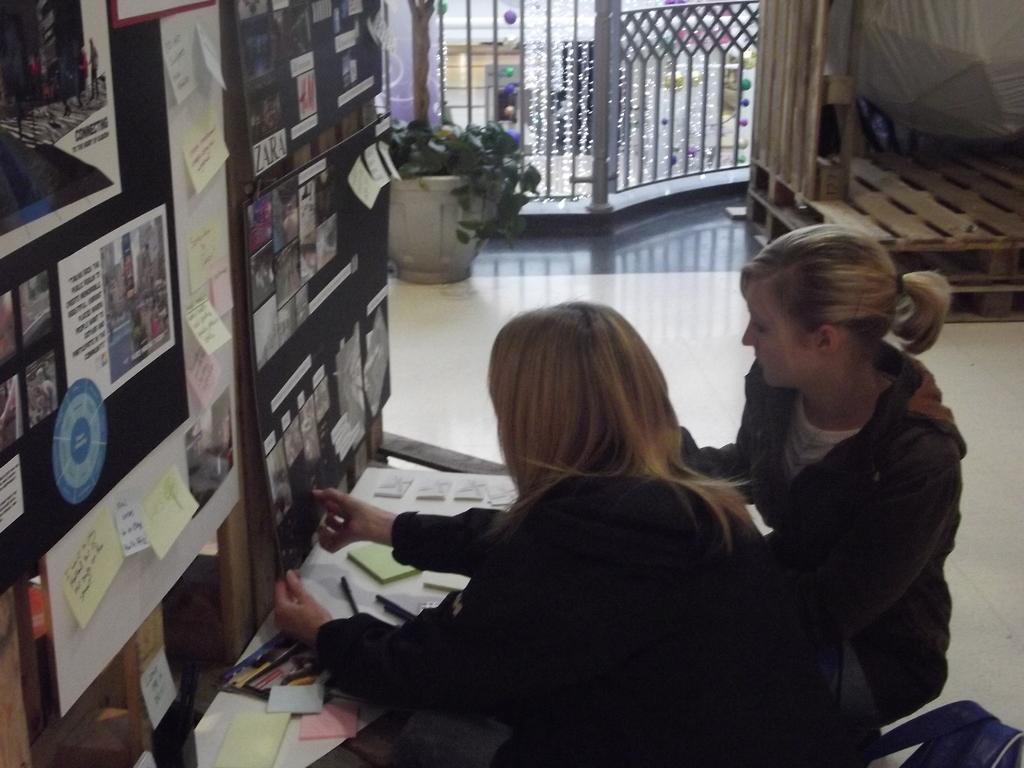Please provide a concise description of this image. In this image we can see two women wearing dress are standing on the floor. One woman is holding a board in her hand. In the foreground of the image we can see group of books and pens placed on the surface, To the left side of the image we can see group of images on the wall. In the background, we can see some pallets on the floor, metal railing, a group of lights and a plant. 